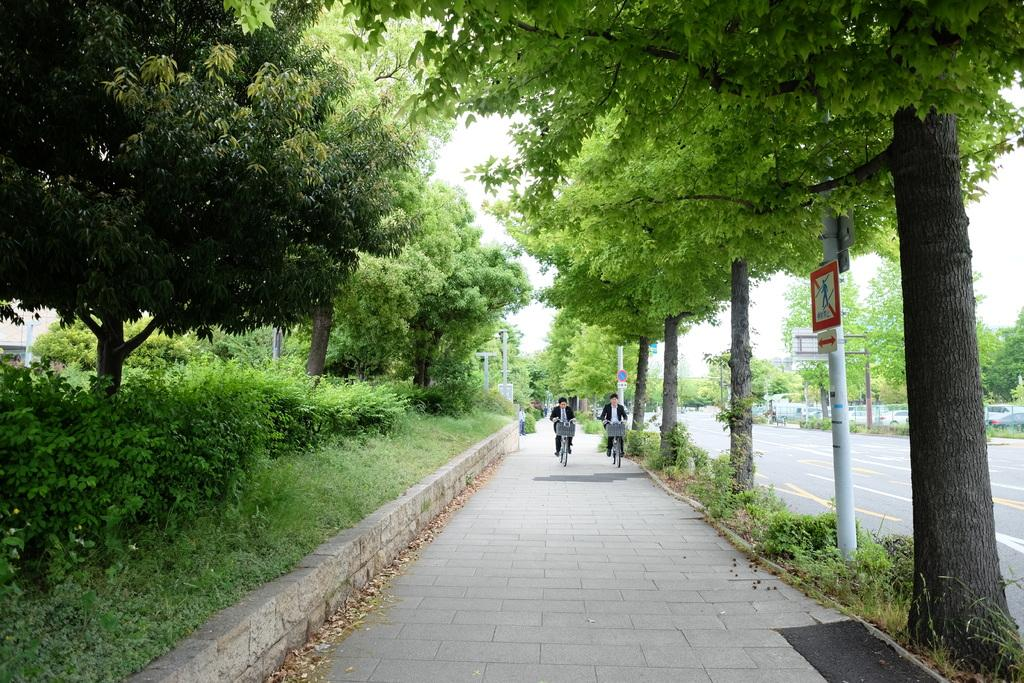What are the two men in the image doing? The two men in the image are cycling. Where are the men cycling? The men are on a pathway. What type of vegetation can be seen in the image? There are plants, grass, and a group of trees in the image. What other objects can be seen in the image? There are sign boards, poles, a car, and the sky is visible in the image. Where are the toys located in the image? There are no toys present in the image. How many spiders can be seen on the seat in the image? There is no seat or spiders present in the image. 